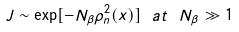<formula> <loc_0><loc_0><loc_500><loc_500>J \sim \exp [ - N _ { \beta } \rho _ { n } ^ { 2 } ( x ) ] \ a t \ N _ { \beta } \gg 1</formula> 